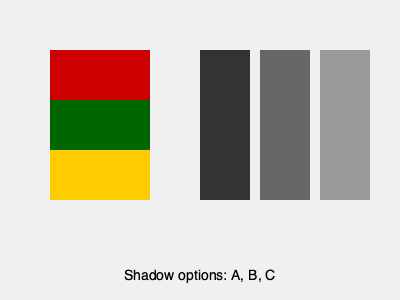Which shadow correctly represents the traditional Lithuanian sash pattern shown above? To determine the correct shadow, we need to analyze the original pattern and compare it to the shadow options:

1. The original pattern consists of three horizontal stripes of equal height.
2. The order of colors from top to bottom is red, green, and yellow.
3. In a shadow, these colors would be represented by different shades of gray.

Now, let's examine the shadow options:

A. This shadow shows three vertical stripes of equal width, which correctly represents the three horizontal stripes of the original pattern.
B. This shadow has two vertical stripes of equal width, which does not match the three-stripe pattern of the original.
C. This shadow shows a single vertical stripe, which does not represent the three-stripe pattern at all.

The correct shadow should maintain the same number of divisions as the original pattern, just rotated 90 degrees. Therefore, option A is the correct shadow representation of the traditional Lithuanian sash pattern.
Answer: A 